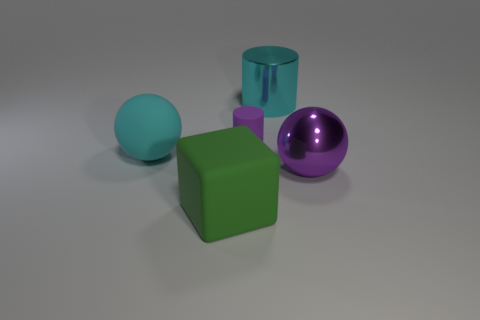There is a large rubber sphere; is it the same color as the matte object in front of the purple metallic sphere?
Keep it short and to the point. No. What shape is the large object that is both behind the metal sphere and in front of the large cylinder?
Provide a short and direct response. Sphere. Is the number of green matte cubes less than the number of tiny blue metallic cylinders?
Make the answer very short. No. Are any small cyan metallic cylinders visible?
Offer a very short reply. No. How many other objects are there of the same size as the purple rubber thing?
Your answer should be compact. 0. Do the large green thing and the object that is right of the cyan shiny cylinder have the same material?
Keep it short and to the point. No. Are there the same number of rubber things that are in front of the large matte cube and purple objects behind the big cyan matte object?
Offer a very short reply. No. What material is the big cyan cylinder?
Your answer should be compact. Metal. There is a metallic ball that is the same size as the cyan cylinder; what color is it?
Make the answer very short. Purple. Is there a purple metallic thing that is left of the cyan object that is behind the cyan rubber ball?
Your response must be concise. No. 